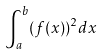<formula> <loc_0><loc_0><loc_500><loc_500>\int _ { a } ^ { b } ( f ( x ) ) ^ { 2 } d x</formula> 